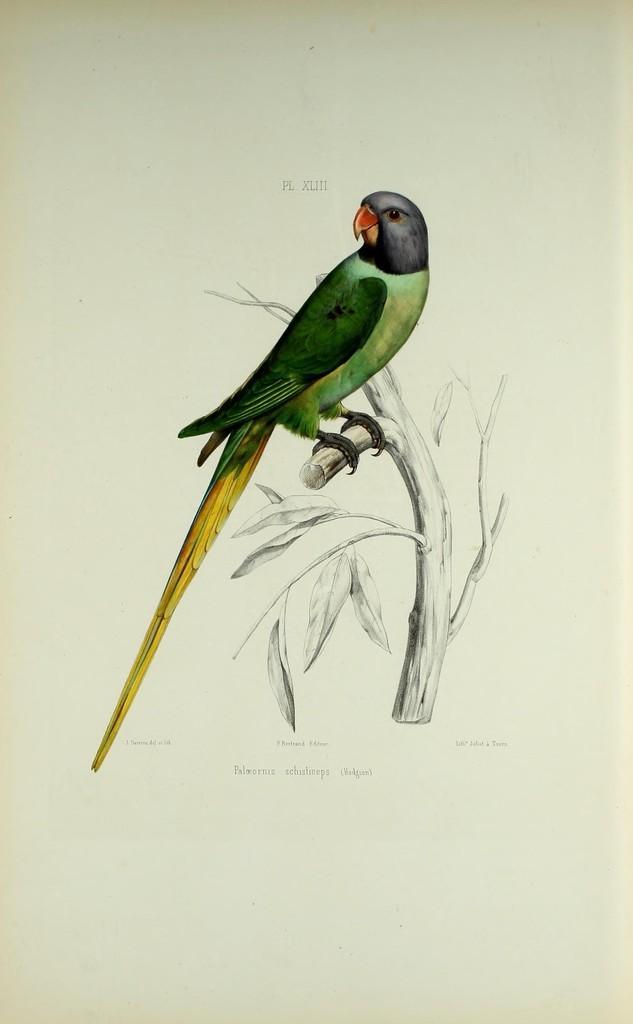Can you describe this image briefly? In this image, we can see a photo, in that photo, we can see a parrot sitting on the plant. 